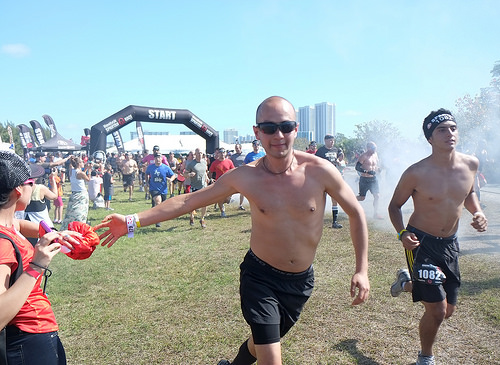<image>
Can you confirm if the girl is to the left of the boy? No. The girl is not to the left of the boy. From this viewpoint, they have a different horizontal relationship. Is there a man behind the building? No. The man is not behind the building. From this viewpoint, the man appears to be positioned elsewhere in the scene. Is the man in front of the woman? Yes. The man is positioned in front of the woman, appearing closer to the camera viewpoint. 